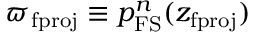<formula> <loc_0><loc_0><loc_500><loc_500>\varpi _ { f p r o j } \equiv p _ { F S } ^ { n } ( z _ { f p r o j } )</formula> 